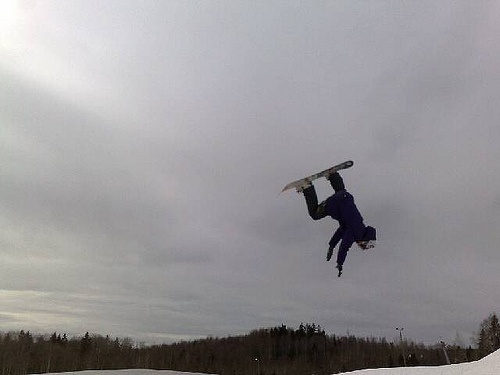Describe the objects in this image and their specific colors. I can see people in white, black, and gray tones and snowboard in white, gray, and black tones in this image. 